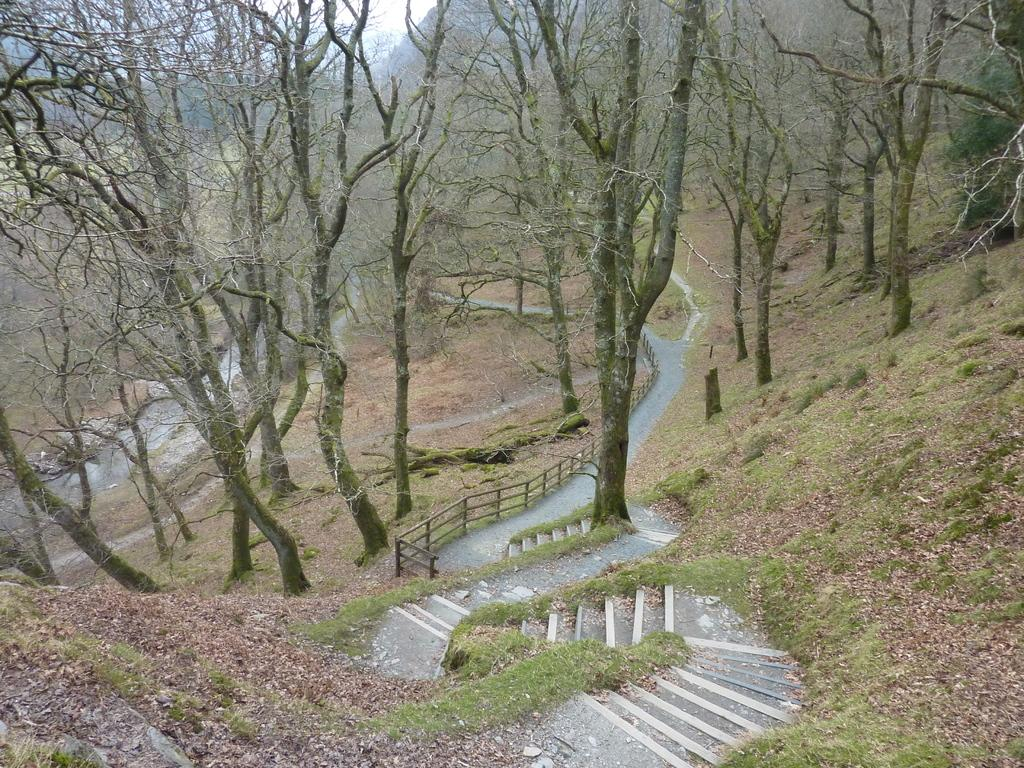What is the main feature of the image? The main feature of the image is a set of stairs surrounded by grass. Where are the stairs located? The stairs are on the land. What else can be seen in the image besides the stairs? There is a path, a fence, trees, hills, and the sky visible in the image. Can you describe the path in the image? The path is located beside the stairs and has a fence next to it. What is visible in the background of the image? Hills and the sky are visible in the background of the image. What is your sister doing with her hands in the image? There is no sister or hands present in the image. 